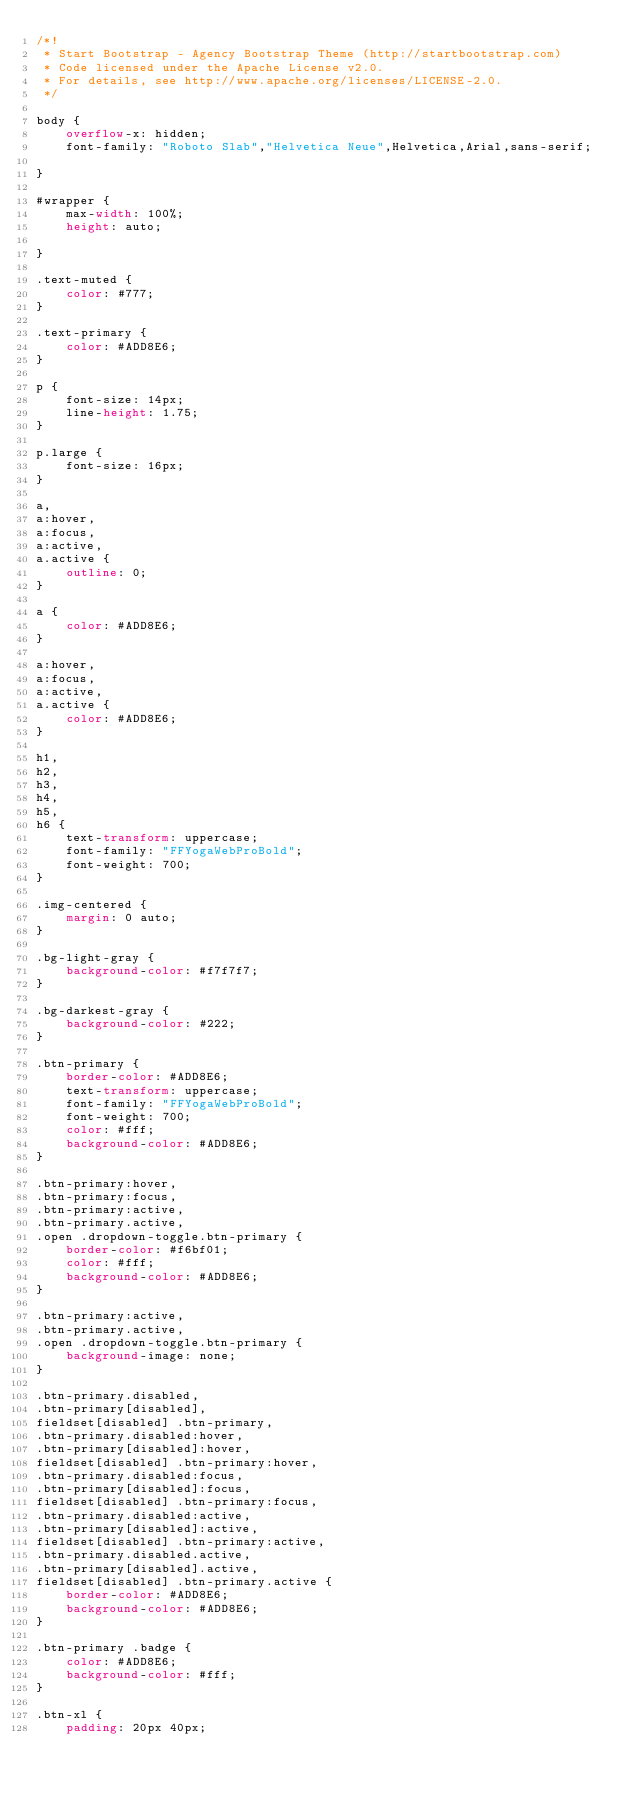Convert code to text. <code><loc_0><loc_0><loc_500><loc_500><_CSS_>/*!
 * Start Bootstrap - Agency Bootstrap Theme (http://startbootstrap.com)
 * Code licensed under the Apache License v2.0.
 * For details, see http://www.apache.org/licenses/LICENSE-2.0.
 */

body {
    overflow-x: hidden;
    font-family: "Roboto Slab","Helvetica Neue",Helvetica,Arial,sans-serif;

}

#wrapper {
    max-width: 100%;
    height: auto;

}

.text-muted {
    color: #777;
}

.text-primary {
    color: #ADD8E6;
}

p {
    font-size: 14px;
    line-height: 1.75;
}

p.large {
    font-size: 16px;
}

a,
a:hover,
a:focus,
a:active,
a.active {
    outline: 0;
}

a {
    color: #ADD8E6;
}

a:hover,
a:focus,
a:active,
a.active {
    color: #ADD8E6;
}

h1,
h2,
h3,
h4,
h5,
h6 {
    text-transform: uppercase;
    font-family: "FFYogaWebProBold";
    font-weight: 700;
}

.img-centered {
    margin: 0 auto;
}

.bg-light-gray {
    background-color: #f7f7f7;
}

.bg-darkest-gray {
    background-color: #222;
}

.btn-primary {
    border-color: #ADD8E6;
    text-transform: uppercase;
    font-family: "FFYogaWebProBold";
    font-weight: 700;
    color: #fff;
    background-color: #ADD8E6;
}

.btn-primary:hover,
.btn-primary:focus,
.btn-primary:active,
.btn-primary.active,
.open .dropdown-toggle.btn-primary {
    border-color: #f6bf01;
    color: #fff;
    background-color: #ADD8E6;
}

.btn-primary:active,
.btn-primary.active,
.open .dropdown-toggle.btn-primary {
    background-image: none;
}

.btn-primary.disabled,
.btn-primary[disabled],
fieldset[disabled] .btn-primary,
.btn-primary.disabled:hover,
.btn-primary[disabled]:hover,
fieldset[disabled] .btn-primary:hover,
.btn-primary.disabled:focus,
.btn-primary[disabled]:focus,
fieldset[disabled] .btn-primary:focus,
.btn-primary.disabled:active,
.btn-primary[disabled]:active,
fieldset[disabled] .btn-primary:active,
.btn-primary.disabled.active,
.btn-primary[disabled].active,
fieldset[disabled] .btn-primary.active {
    border-color: #ADD8E6;
    background-color: #ADD8E6;
}

.btn-primary .badge {
    color: #ADD8E6;
    background-color: #fff;
}

.btn-xl {
    padding: 20px 40px;</code> 